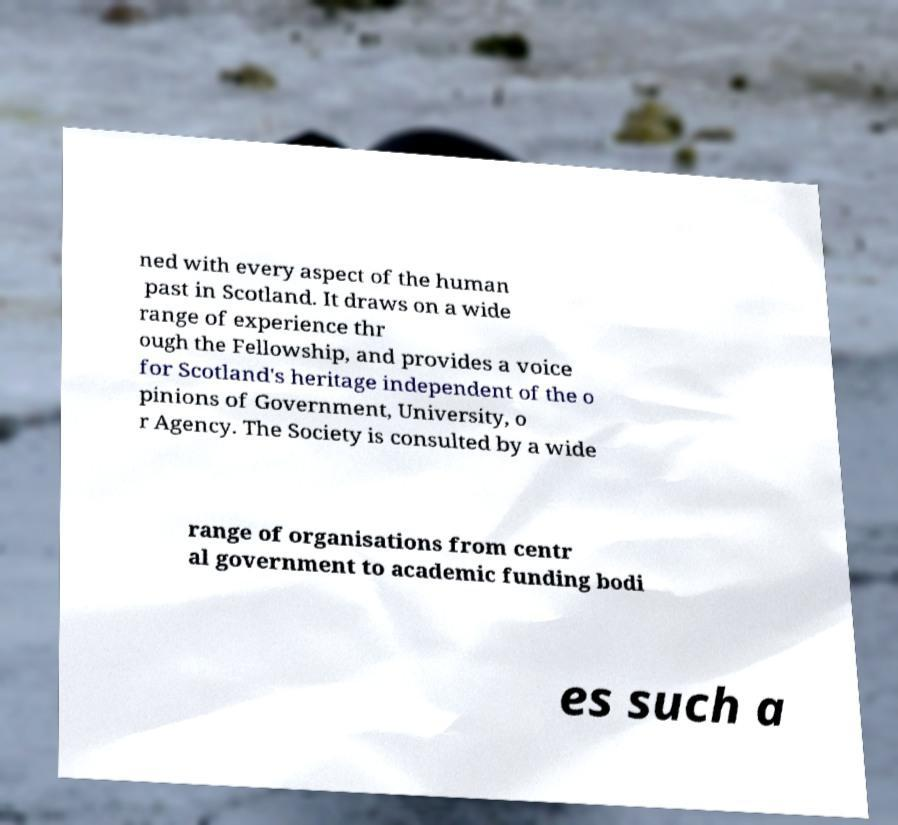Can you read and provide the text displayed in the image?This photo seems to have some interesting text. Can you extract and type it out for me? ned with every aspect of the human past in Scotland. It draws on a wide range of experience thr ough the Fellowship, and provides a voice for Scotland's heritage independent of the o pinions of Government, University, o r Agency. The Society is consulted by a wide range of organisations from centr al government to academic funding bodi es such a 